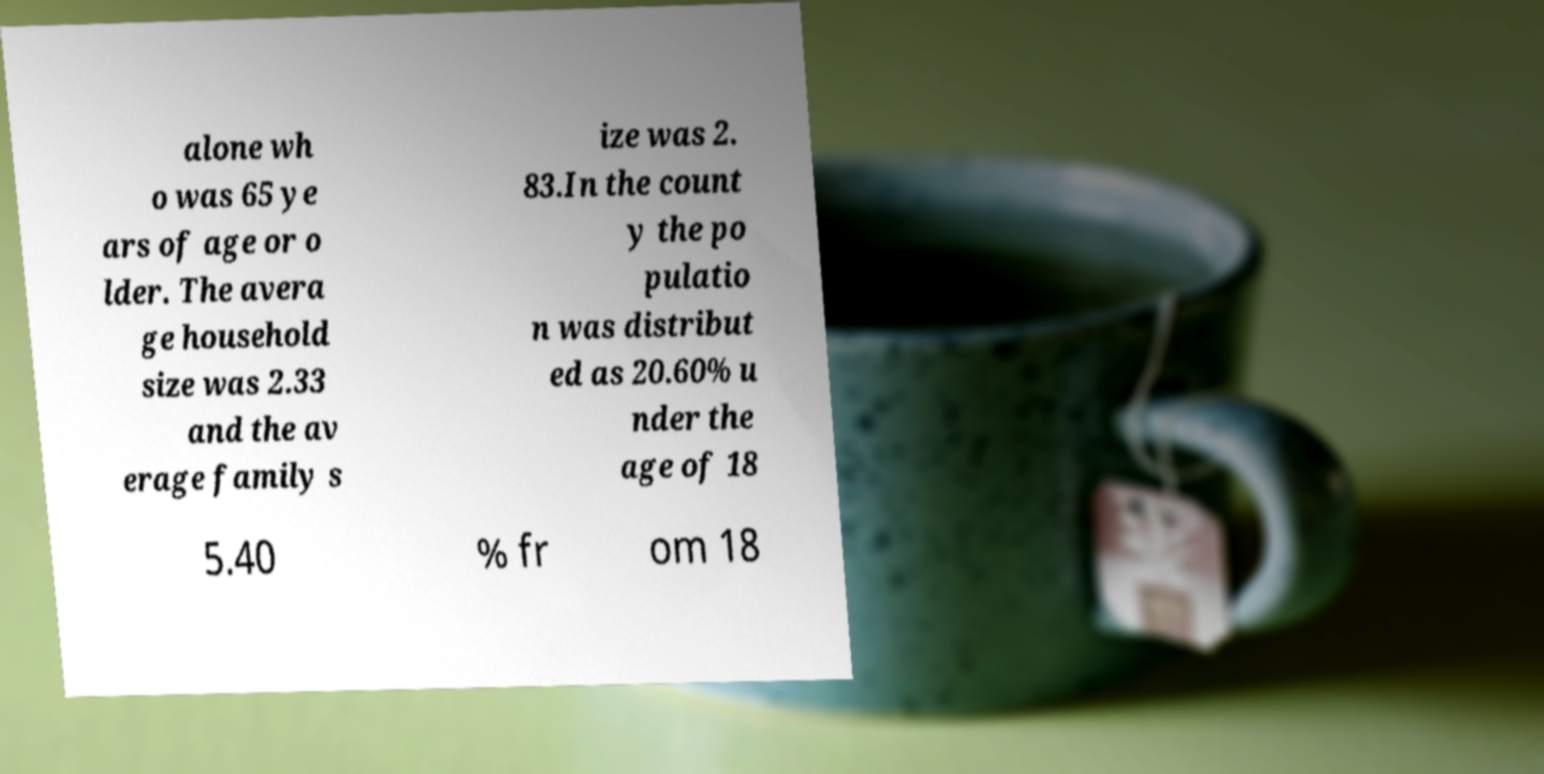Can you read and provide the text displayed in the image?This photo seems to have some interesting text. Can you extract and type it out for me? alone wh o was 65 ye ars of age or o lder. The avera ge household size was 2.33 and the av erage family s ize was 2. 83.In the count y the po pulatio n was distribut ed as 20.60% u nder the age of 18 5.40 % fr om 18 